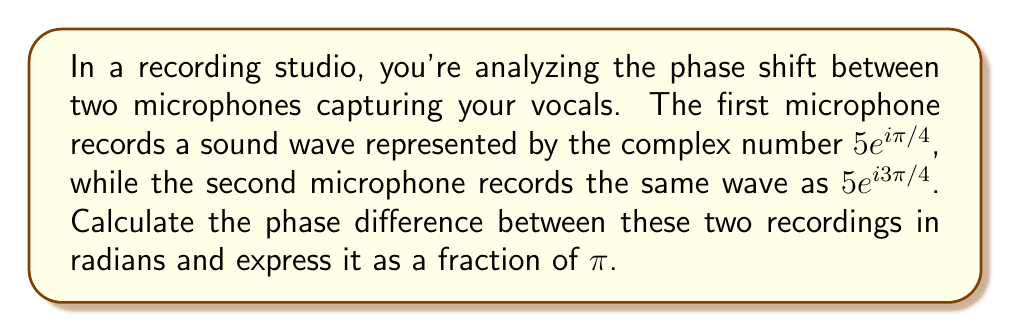Solve this math problem. To find the phase difference between the two recordings, we need to follow these steps:

1) The two recorded waves are represented in polar form as:
   Wave 1: $z_1 = 5e^{i\pi/4}$
   Wave 2: $z_2 = 5e^{i3\pi/4}$

2) In the polar form $re^{i\theta}$, the angle $\theta$ represents the phase of the wave.

3) For $z_1$, the phase is $\theta_1 = \pi/4$
   For $z_2$, the phase is $\theta_2 = 3\pi/4$

4) The phase difference is the absolute difference between these angles:

   $$\Delta\theta = |\theta_2 - \theta_1| = |3\pi/4 - \pi/4| = |2\pi/4| = \pi/2$$

5) This result is already expressed as a fraction of $\pi$.

Therefore, the phase difference between the two recordings is $\pi/2$ radians.
Answer: $\pi/2$ radians 